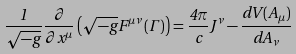<formula> <loc_0><loc_0><loc_500><loc_500>\frac { 1 } { \sqrt { - g } } \frac { \partial } { \partial x ^ { \mu } } \left ( \sqrt { - g } F ^ { \mu \nu } \left ( \Gamma \right ) \right ) = \frac { 4 \pi } { c } J ^ { \nu } - \frac { d V ( A _ { \mu } ) } { d A _ { \nu } }</formula> 